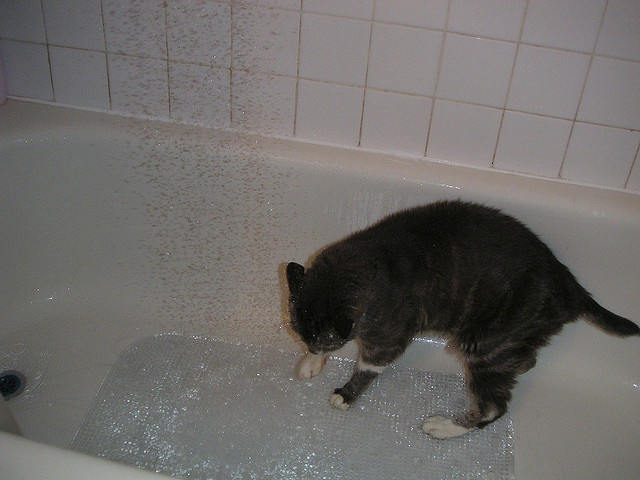Describe the objects in this image and their specific colors. I can see a cat in black and gray tones in this image. 